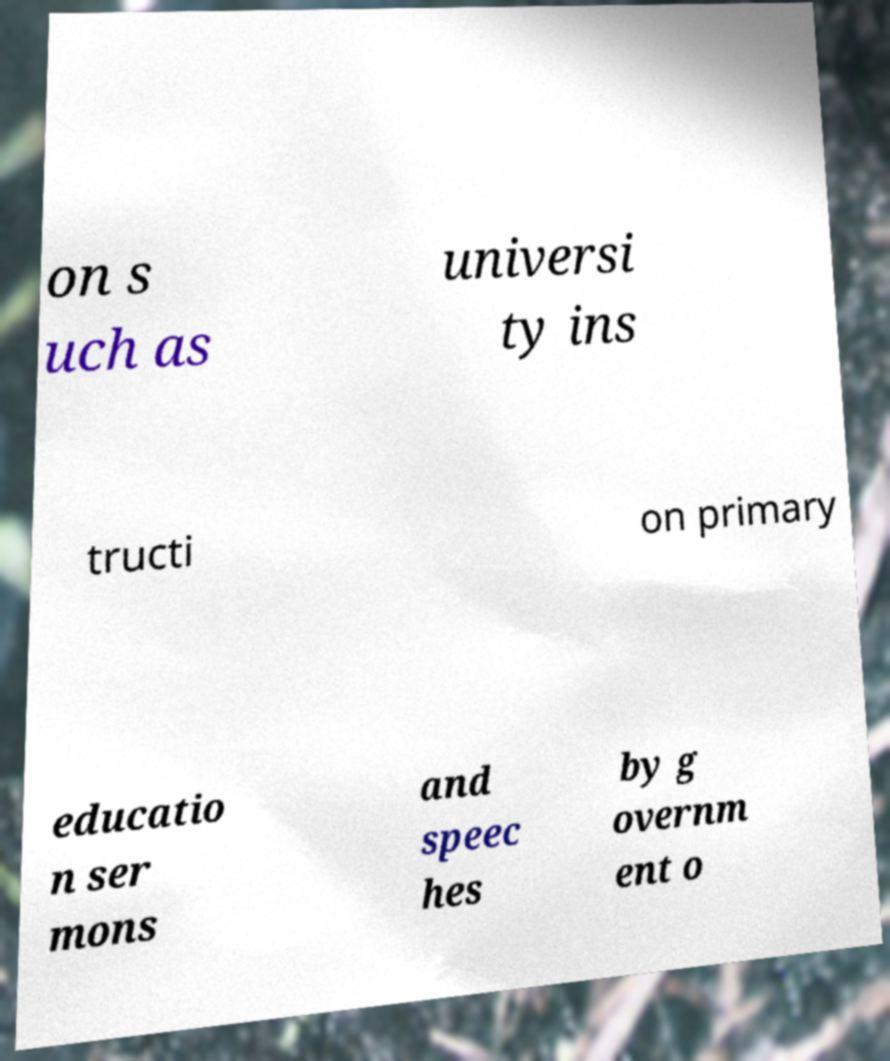I need the written content from this picture converted into text. Can you do that? on s uch as universi ty ins tructi on primary educatio n ser mons and speec hes by g overnm ent o 